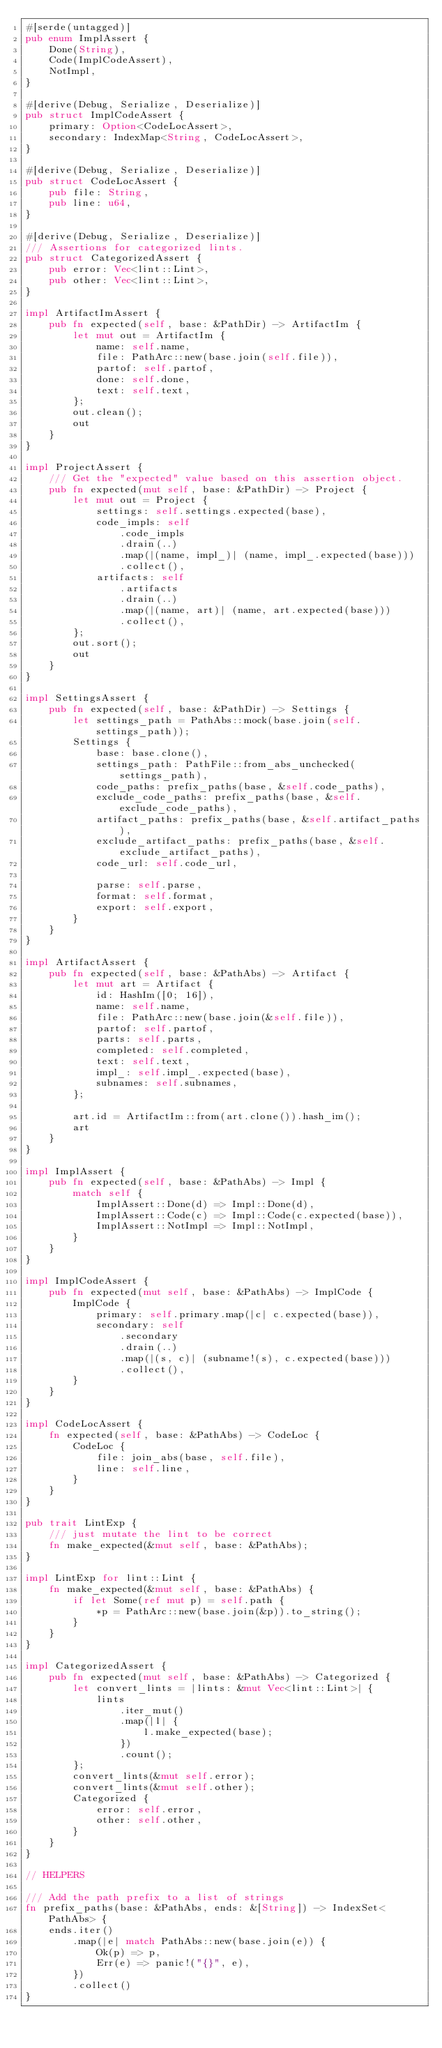Convert code to text. <code><loc_0><loc_0><loc_500><loc_500><_Rust_>#[serde(untagged)]
pub enum ImplAssert {
    Done(String),
    Code(ImplCodeAssert),
    NotImpl,
}

#[derive(Debug, Serialize, Deserialize)]
pub struct ImplCodeAssert {
    primary: Option<CodeLocAssert>,
    secondary: IndexMap<String, CodeLocAssert>,
}

#[derive(Debug, Serialize, Deserialize)]
pub struct CodeLocAssert {
    pub file: String,
    pub line: u64,
}

#[derive(Debug, Serialize, Deserialize)]
/// Assertions for categorized lints.
pub struct CategorizedAssert {
    pub error: Vec<lint::Lint>,
    pub other: Vec<lint::Lint>,
}

impl ArtifactImAssert {
    pub fn expected(self, base: &PathDir) -> ArtifactIm {
        let mut out = ArtifactIm {
            name: self.name,
            file: PathArc::new(base.join(self.file)),
            partof: self.partof,
            done: self.done,
            text: self.text,
        };
        out.clean();
        out
    }
}

impl ProjectAssert {
    /// Get the "expected" value based on this assertion object.
    pub fn expected(mut self, base: &PathDir) -> Project {
        let mut out = Project {
            settings: self.settings.expected(base),
            code_impls: self
                .code_impls
                .drain(..)
                .map(|(name, impl_)| (name, impl_.expected(base)))
                .collect(),
            artifacts: self
                .artifacts
                .drain(..)
                .map(|(name, art)| (name, art.expected(base)))
                .collect(),
        };
        out.sort();
        out
    }
}

impl SettingsAssert {
    pub fn expected(self, base: &PathDir) -> Settings {
        let settings_path = PathAbs::mock(base.join(self.settings_path));
        Settings {
            base: base.clone(),
            settings_path: PathFile::from_abs_unchecked(settings_path),
            code_paths: prefix_paths(base, &self.code_paths),
            exclude_code_paths: prefix_paths(base, &self.exclude_code_paths),
            artifact_paths: prefix_paths(base, &self.artifact_paths),
            exclude_artifact_paths: prefix_paths(base, &self.exclude_artifact_paths),
            code_url: self.code_url,

            parse: self.parse,
            format: self.format,
            export: self.export,
        }
    }
}

impl ArtifactAssert {
    pub fn expected(self, base: &PathAbs) -> Artifact {
        let mut art = Artifact {
            id: HashIm([0; 16]),
            name: self.name,
            file: PathArc::new(base.join(&self.file)),
            partof: self.partof,
            parts: self.parts,
            completed: self.completed,
            text: self.text,
            impl_: self.impl_.expected(base),
            subnames: self.subnames,
        };

        art.id = ArtifactIm::from(art.clone()).hash_im();
        art
    }
}

impl ImplAssert {
    pub fn expected(self, base: &PathAbs) -> Impl {
        match self {
            ImplAssert::Done(d) => Impl::Done(d),
            ImplAssert::Code(c) => Impl::Code(c.expected(base)),
            ImplAssert::NotImpl => Impl::NotImpl,
        }
    }
}

impl ImplCodeAssert {
    pub fn expected(mut self, base: &PathAbs) -> ImplCode {
        ImplCode {
            primary: self.primary.map(|c| c.expected(base)),
            secondary: self
                .secondary
                .drain(..)
                .map(|(s, c)| (subname!(s), c.expected(base)))
                .collect(),
        }
    }
}

impl CodeLocAssert {
    fn expected(self, base: &PathAbs) -> CodeLoc {
        CodeLoc {
            file: join_abs(base, self.file),
            line: self.line,
        }
    }
}

pub trait LintExp {
    /// just mutate the lint to be correct
    fn make_expected(&mut self, base: &PathAbs);
}

impl LintExp for lint::Lint {
    fn make_expected(&mut self, base: &PathAbs) {
        if let Some(ref mut p) = self.path {
            *p = PathArc::new(base.join(&p)).to_string();
        }
    }
}

impl CategorizedAssert {
    pub fn expected(mut self, base: &PathAbs) -> Categorized {
        let convert_lints = |lints: &mut Vec<lint::Lint>| {
            lints
                .iter_mut()
                .map(|l| {
                    l.make_expected(base);
                })
                .count();
        };
        convert_lints(&mut self.error);
        convert_lints(&mut self.other);
        Categorized {
            error: self.error,
            other: self.other,
        }
    }
}

// HELPERS

/// Add the path prefix to a list of strings
fn prefix_paths(base: &PathAbs, ends: &[String]) -> IndexSet<PathAbs> {
    ends.iter()
        .map(|e| match PathAbs::new(base.join(e)) {
            Ok(p) => p,
            Err(e) => panic!("{}", e),
        })
        .collect()
}
</code> 